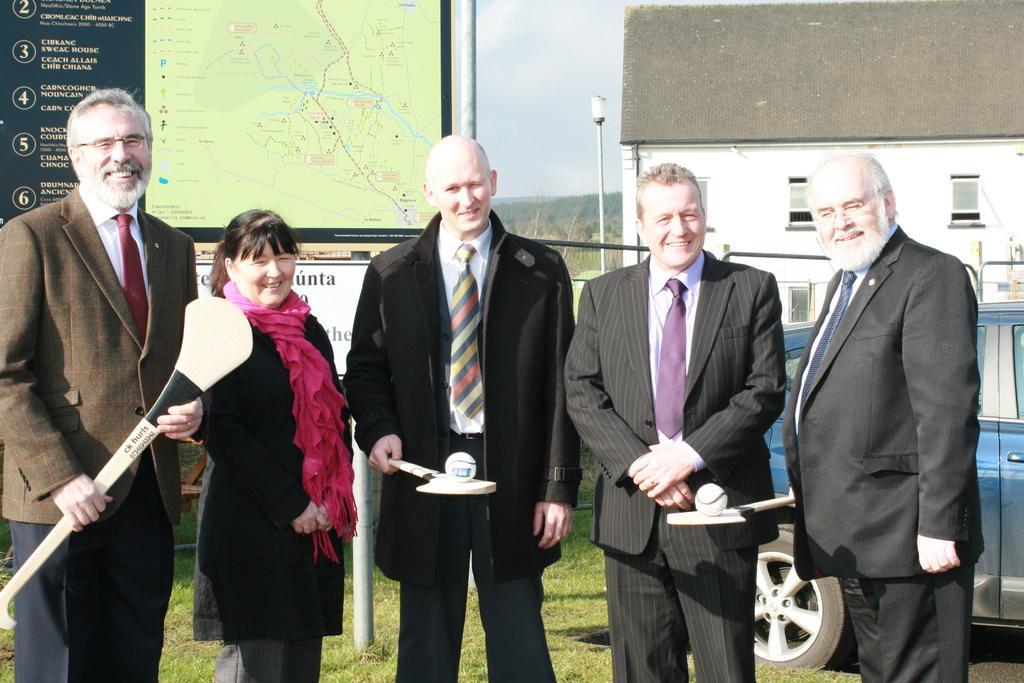Can you describe this image briefly? In this image I can see group of people standing, the person in front is wearing black blazer, white shirt and holding a bat and a ball. Background I can see a banner, few vehicles, building in white color, a light pole and the sky is in white color and I can see trees and grass in green color. 